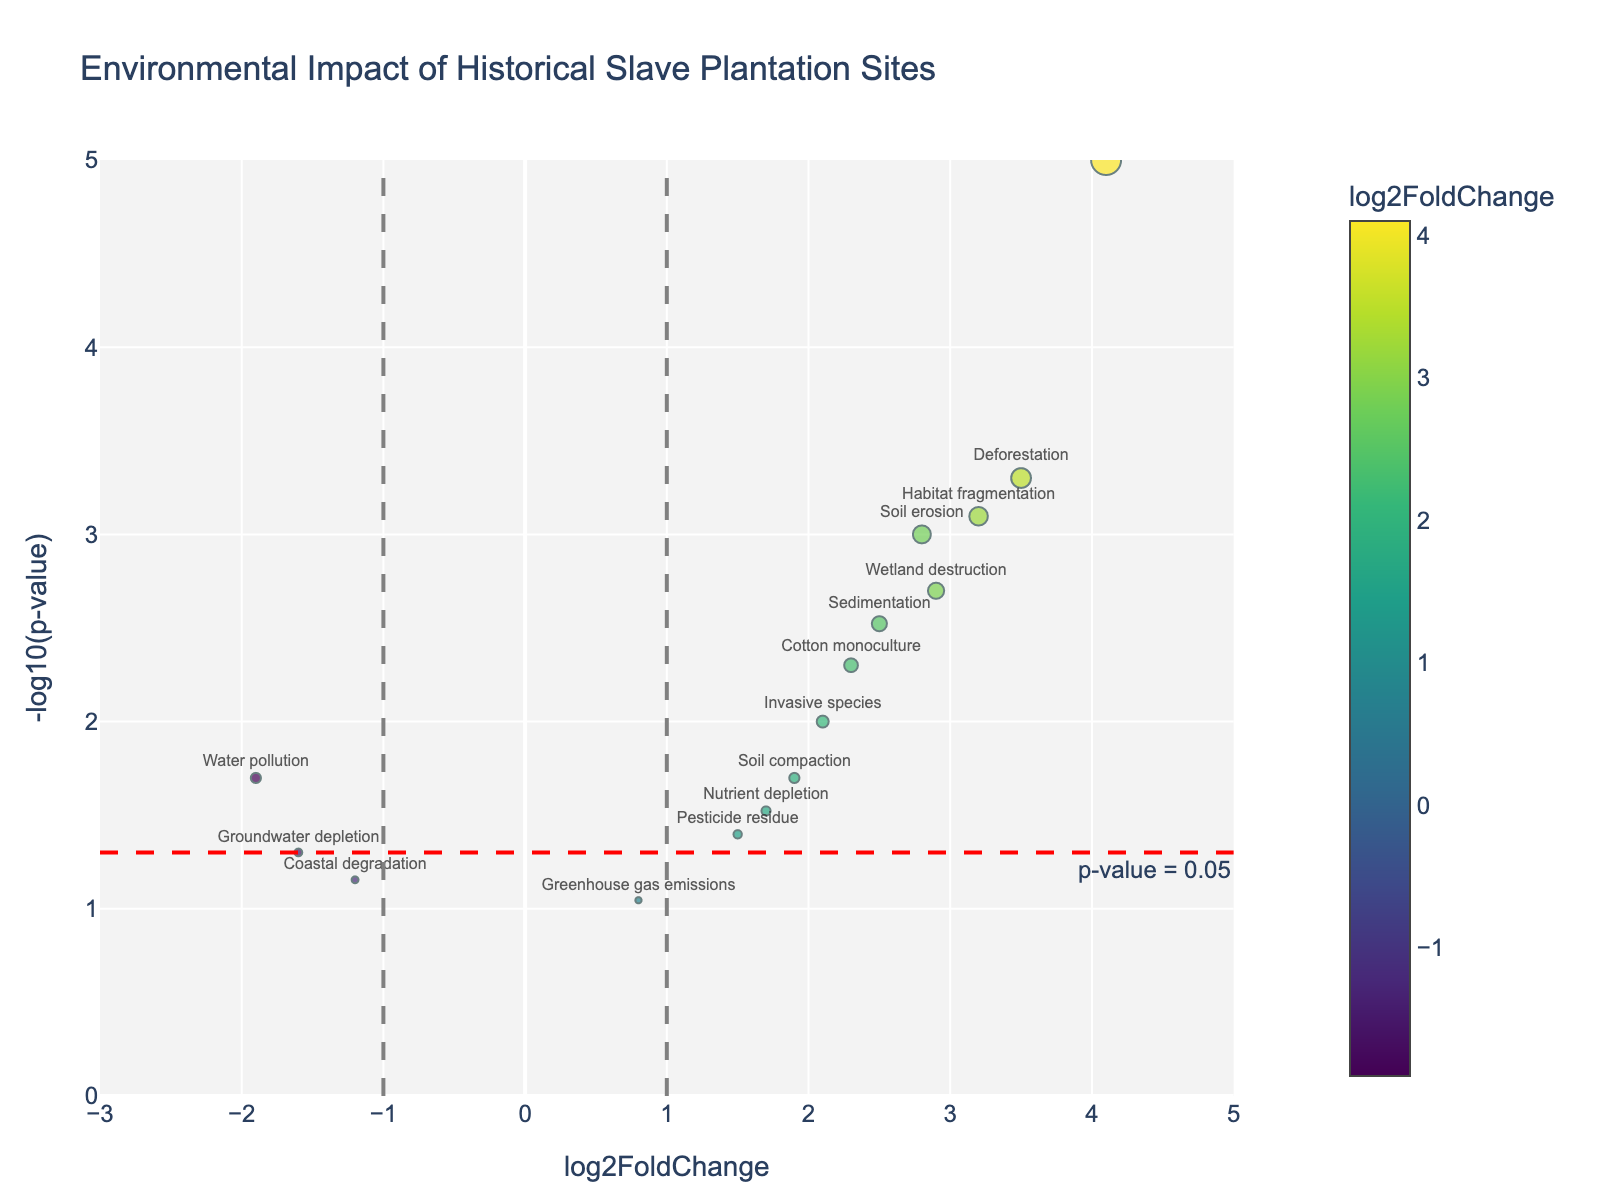What is the title of the plot? The title of the plot is located at the top center of the figure. It is set to provide a context for the data being visualized. The given title in this case is 'Environmental Impact of Historical Slave Plantation Sites'.
Answer: Environmental Impact of Historical Slave Plantation Sites How many environmental impacts have a p-value less than 0.05? To determine this, look for points above the horizontal red dashed line, which represents a p-value threshold of 0.05. Count these data points. There are 11 such points: Soil erosion, Deforestation, Biodiversity loss, Cotton monoculture, Wetland destruction, Invasive species, Habitat fragmentation, Sedimentation, Soil compaction, Water pollution, and Pesticide residue.
Answer: 11 Which environmental impact has the highest log2FoldChange value? Identify the point that is farthest to the right along the x-axis. The label 'Biodiversity loss' corresponds to this point, indicating it has the highest log2FoldChange value of 4.1.
Answer: Biodiversity loss What is the log2FoldChange and p-value for 'Sedimentation'? Find the point labeled 'Sedimentation' on the plot. The hovertext shows log2FoldChange as 2.5 and the p-value as 0.003.
Answer: log2FoldChange: 2.5, p-value: 0.003 Compare the log2FoldChange of Soil erosion and Wetland destruction. Which one has a higher value? Look at the x-axis positions of the points labeled 'Soil erosion' and 'Wetland destruction'. Soil erosion is at 2.8 and Wetland destruction at 2.9. Wetland destruction has a higher log2FoldChange value.
Answer: Wetland destruction Which environmental impacts are located in the negative log2FoldChange region and have a p-value less than 0.05? Identify points in the negative side (left of zero) of the x-axis and above the horizontal red dashed line. Water pollution and Groundwater depletion are such impacts.
Answer: Water pollution, Groundwater depletion What does the vertical grey dashed line at x = 1 signify? The vertical grey dashed lines typically represent thresholds for log2FoldChange. Here, x = 1 indicates a log2FoldChange value of 1, beyond which changes may be considered substantial or biologically significant.
Answer: Log2FoldChange threshold Which environmental impact has the smallest p-value? The point that is highest on the y-axis (-log10(p-value)) will represent the smallest p-value. 'Biodiversity loss' is the highest point with the smallest p-value.
Answer: Biodiversity loss What does the color of the marker represent? The color of each point correlates with its log2FoldChange value, using a colorscale for visual representation.
Answer: Log2FoldChange value 